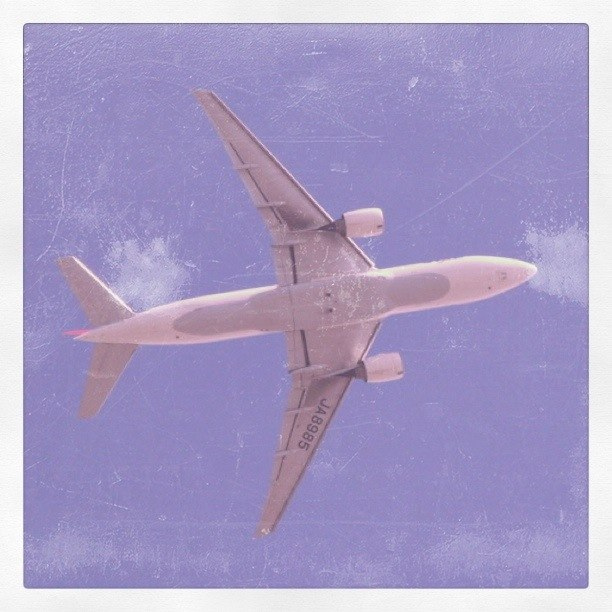Please extract the text content from this image. JA8985 